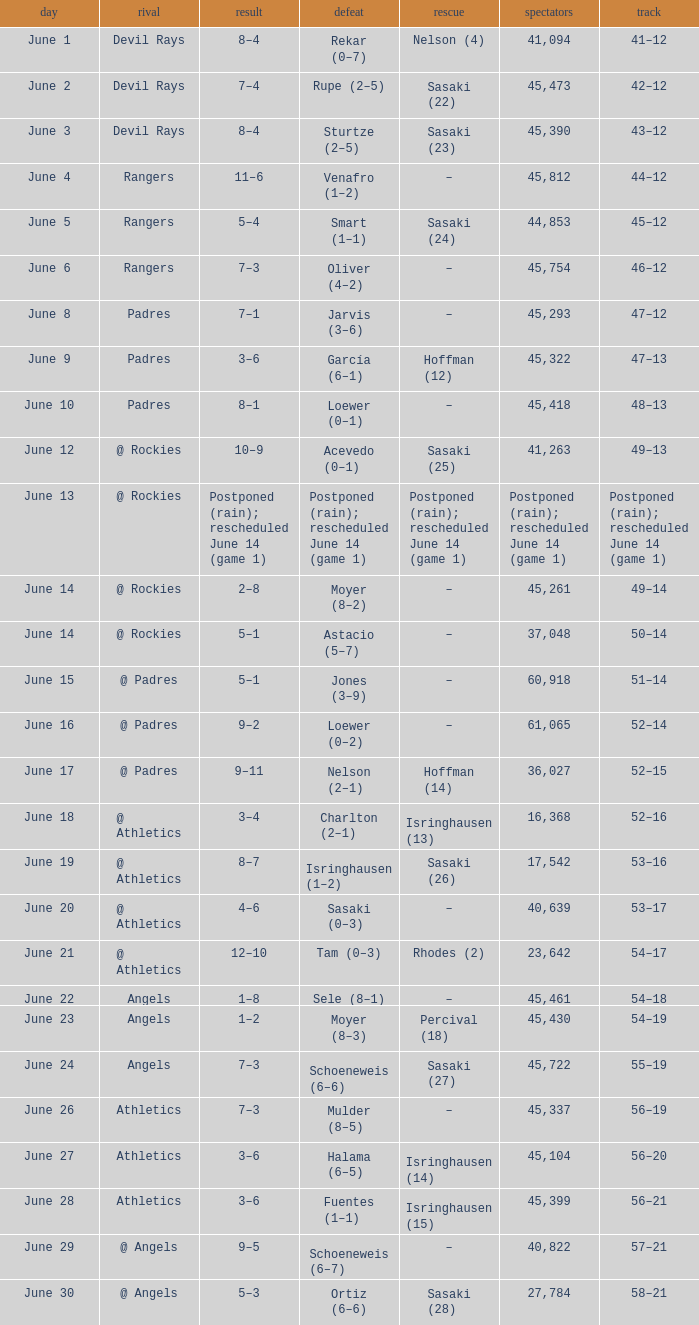What was the date of the Mariners game when they had a record of 53–17? June 20. 